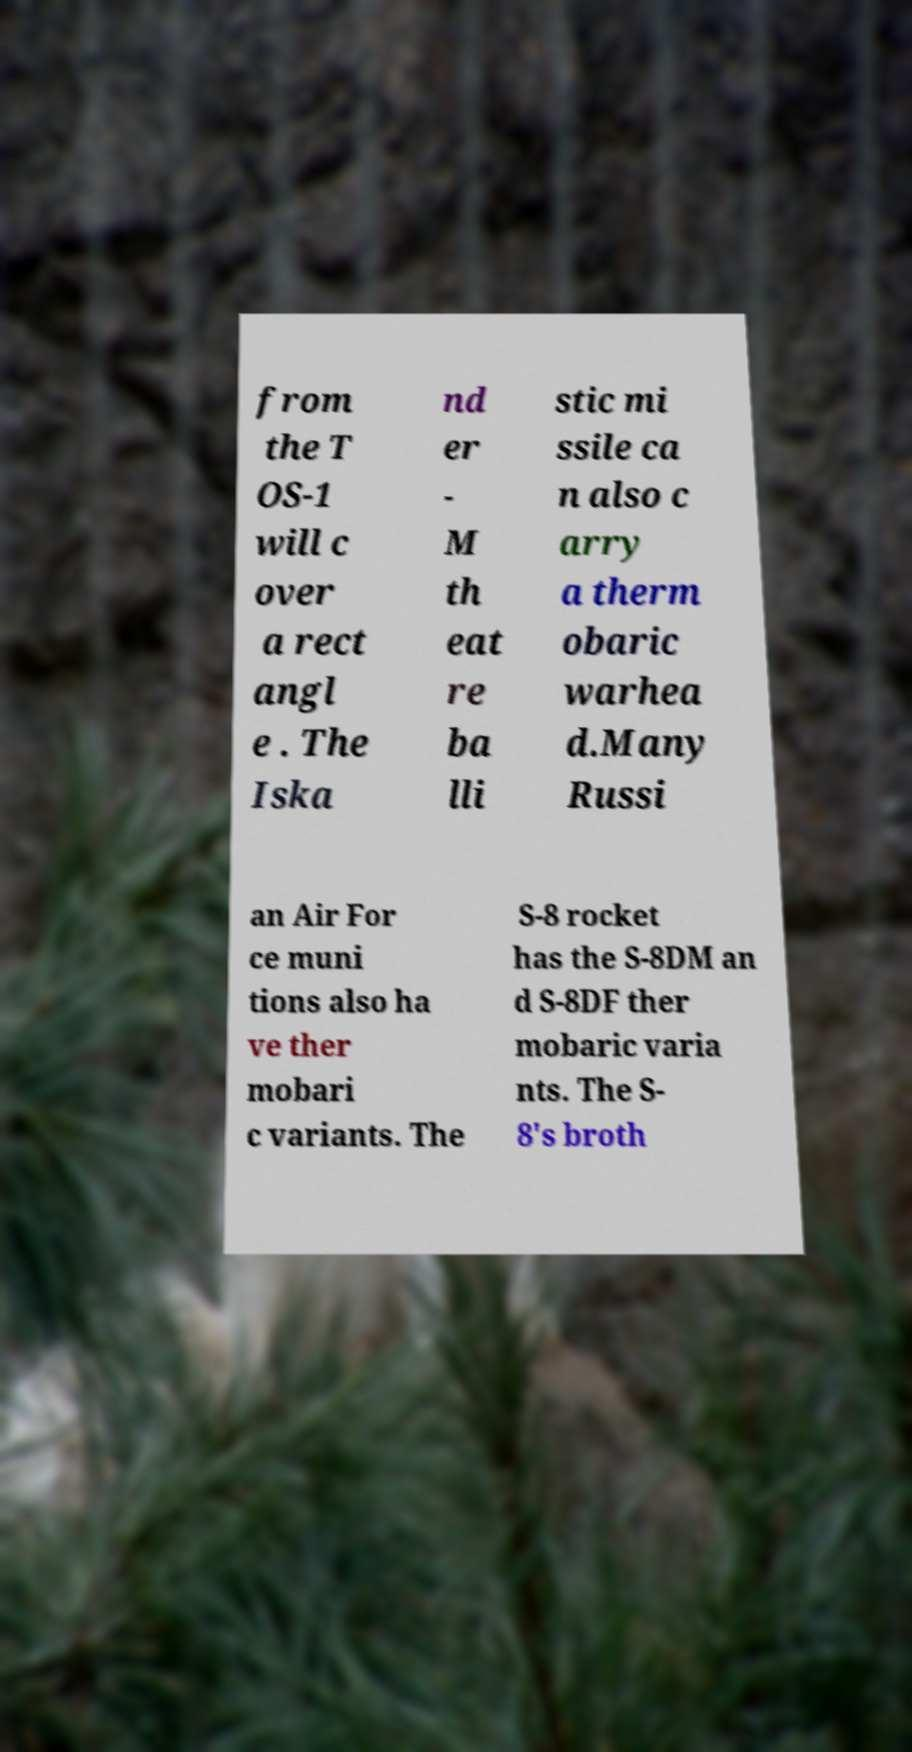Could you assist in decoding the text presented in this image and type it out clearly? from the T OS-1 will c over a rect angl e . The Iska nd er - M th eat re ba lli stic mi ssile ca n also c arry a therm obaric warhea d.Many Russi an Air For ce muni tions also ha ve ther mobari c variants. The S-8 rocket has the S-8DM an d S-8DF ther mobaric varia nts. The S- 8's broth 